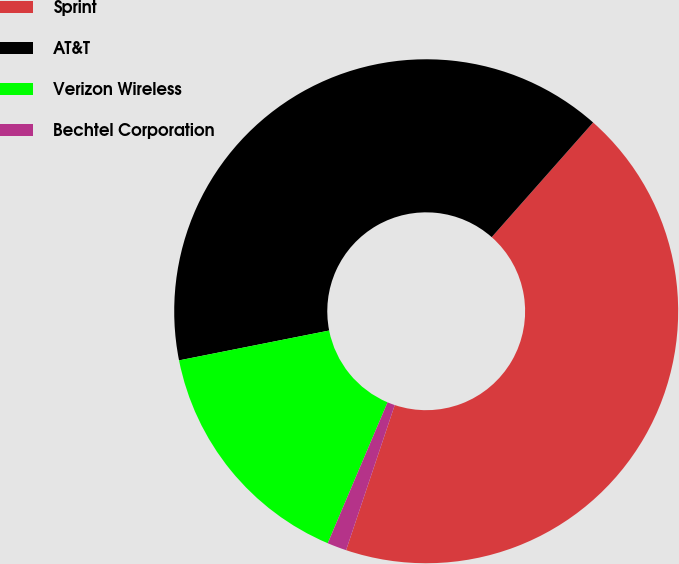<chart> <loc_0><loc_0><loc_500><loc_500><pie_chart><fcel>Sprint<fcel>AT&T<fcel>Verizon Wireless<fcel>Bechtel Corporation<nl><fcel>43.63%<fcel>39.65%<fcel>15.49%<fcel>1.24%<nl></chart> 